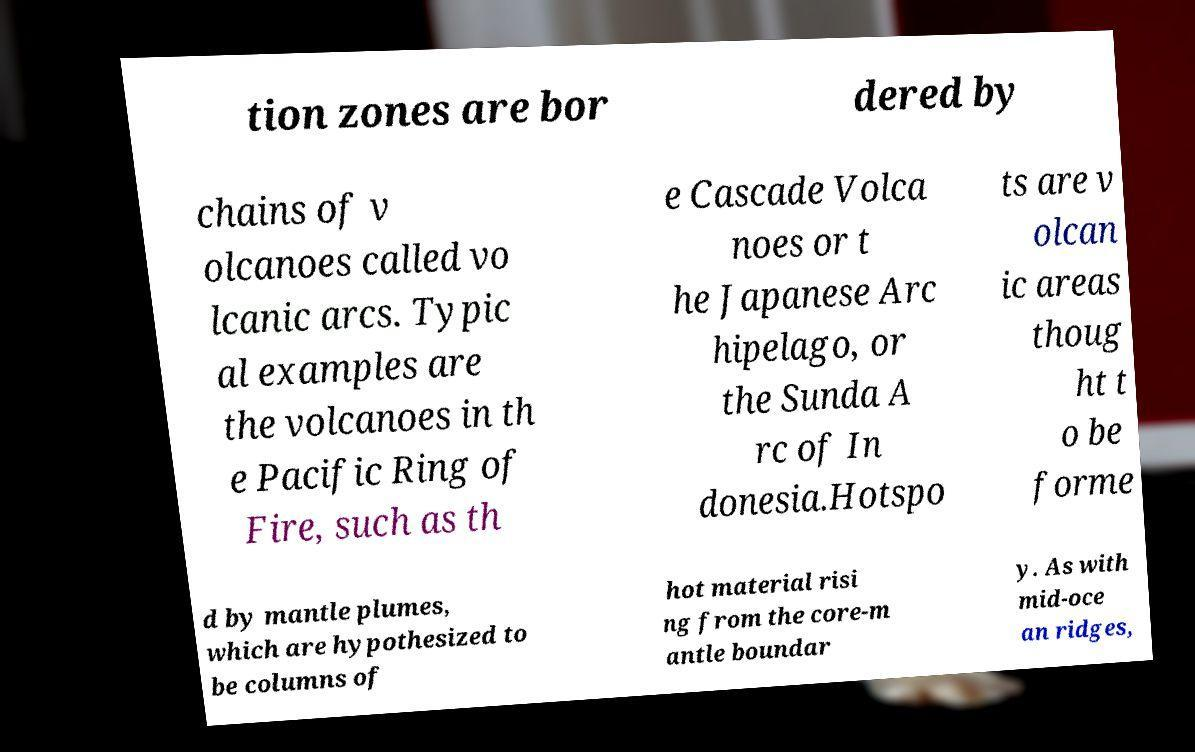Please read and relay the text visible in this image. What does it say? tion zones are bor dered by chains of v olcanoes called vo lcanic arcs. Typic al examples are the volcanoes in th e Pacific Ring of Fire, such as th e Cascade Volca noes or t he Japanese Arc hipelago, or the Sunda A rc of In donesia.Hotspo ts are v olcan ic areas thoug ht t o be forme d by mantle plumes, which are hypothesized to be columns of hot material risi ng from the core-m antle boundar y. As with mid-oce an ridges, 